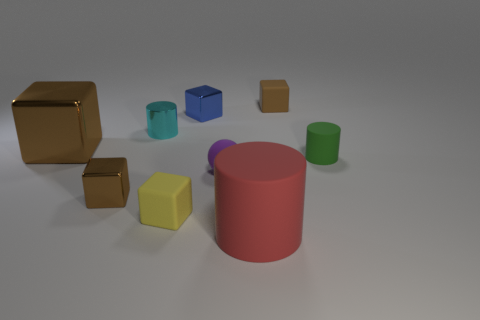Are there any brown matte things of the same size as the blue shiny cube?
Provide a short and direct response. Yes. What number of objects are both on the right side of the tiny blue object and to the left of the big red cylinder?
Your response must be concise. 1. What number of small yellow matte things are on the right side of the tiny brown rubber object?
Make the answer very short. 0. Is there a brown shiny thing that has the same shape as the yellow thing?
Offer a terse response. Yes. There is a cyan object; is it the same shape as the large thing that is behind the purple matte object?
Provide a short and direct response. No. What number of blocks are either purple matte objects or big red objects?
Your answer should be compact. 0. What shape is the brown shiny thing that is in front of the tiny purple sphere?
Ensure brevity in your answer.  Cube. How many other tiny green cylinders have the same material as the tiny green cylinder?
Offer a terse response. 0. Are there fewer large brown shiny objects in front of the big brown shiny cube than tiny brown matte blocks?
Give a very brief answer. Yes. What size is the cylinder in front of the matte object left of the small ball?
Give a very brief answer. Large. 